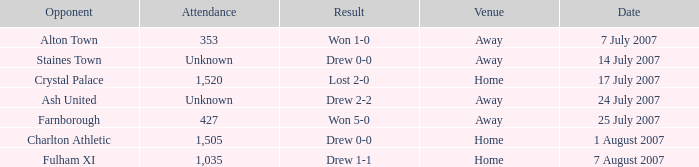Name the attendance with result of won 1-0 353.0. 